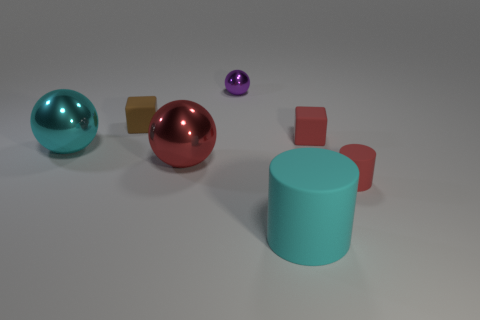The big cyan object that is the same material as the small brown block is what shape?
Offer a very short reply. Cylinder. Is the tiny red cube made of the same material as the cylinder on the right side of the cyan rubber cylinder?
Keep it short and to the point. Yes. What is the color of the small matte object that is left of the tiny matte cube that is right of the purple metallic sphere?
Your response must be concise. Brown. Are there any large things of the same color as the big rubber cylinder?
Provide a short and direct response. Yes. There is a red rubber object behind the red rubber object to the right of the red cube that is to the right of the tiny brown block; what is its size?
Offer a terse response. Small. Do the tiny purple metal thing and the cyan thing behind the red sphere have the same shape?
Offer a very short reply. Yes. What number of other things are the same size as the red sphere?
Your answer should be compact. 2. There is a rubber block on the right side of the big red shiny object; what size is it?
Your answer should be very brief. Small. How many other spheres are made of the same material as the purple ball?
Your answer should be compact. 2. Does the metal thing that is in front of the cyan ball have the same shape as the small purple object?
Offer a very short reply. Yes. 